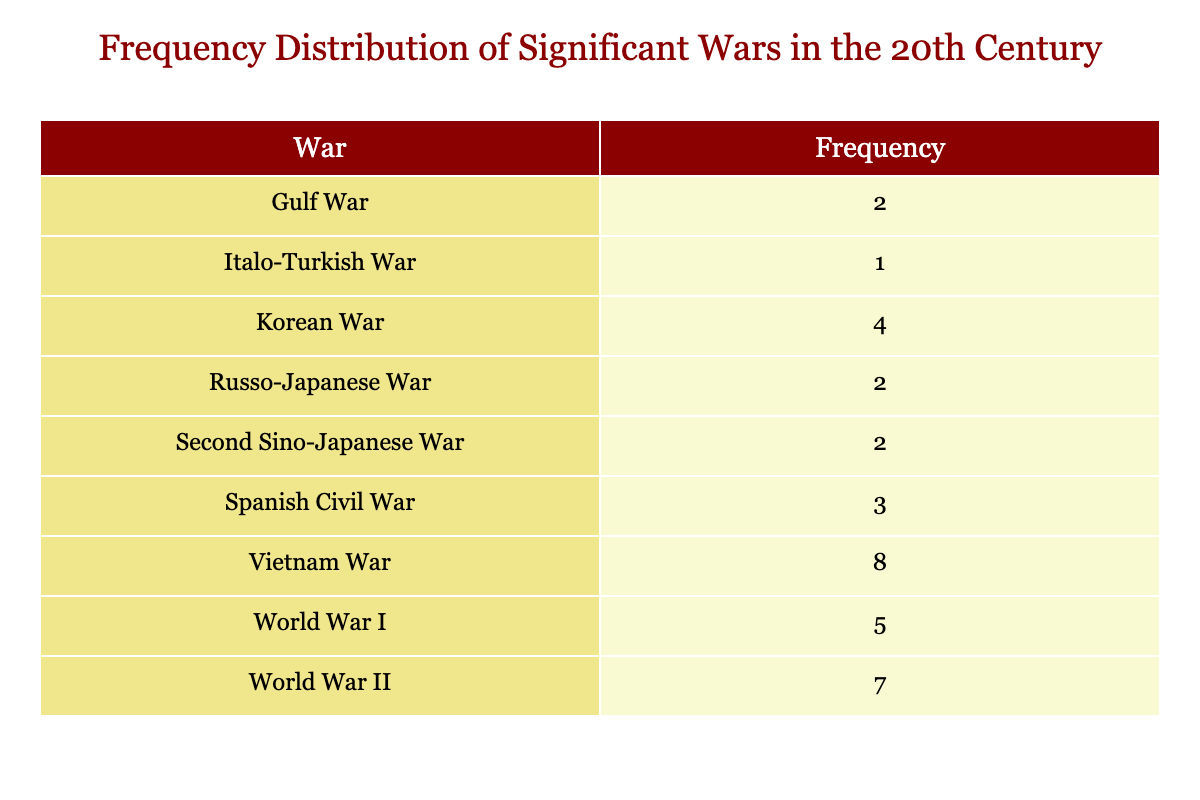What was the most frequent war in the 20th century according to the table? By examining the 'Frequency' column, we can identify the war with the highest count. The table indicates that the Vietnam War appears the most, with a frequency of 8.
Answer: Vietnam War How many significant wars occurred between 1940 and 1945? We look at the years from 1940 to 1945 in the table and count the wars listed: World War II occurred every year within this range. Thus, there is only one war during this time period.
Answer: 1 Is there any year without recorded wars? By scanning the 'Wars' column, multiple years show a '0' value indicating no wars occurred. For example, 1900 to 1903 shows no wars. Hence, the answer is yes.
Answer: Yes What is the total frequency of the wars listed in the table? We sum the frequencies of all wars: Russo-Japanese War (2) + Italo-Turkish War (1) + World War I (5) + Second Sino-Japanese War (2) + Spanish Civil War (3) + World War II (7) + Korean War (4) + Vietnam War (8) + Gulf War (2) = 34
Answer: 34 Which war had the longest span of years listed in the data? By inspecting the years associated with each war, the Vietnam War spans from 1964 to 1975, resulting in a total of 12 years (including both start and end years). Other wars like World War II and the Korean War also had multiple years, but the Vietnam War held the longest duration.
Answer: Vietnam War How many years did not have any significant wars? By reviewing the table, we count the years that are marked with '0.' There are numerous such years. After counting, we find there are 63 years without wars.
Answer: 63 Did the Korean War start before the Gulf War? Comparing the starting years of both wars shows that the Korean War began in 1950, while the Gulf War started in 1990. Thus, the Korean War did start earlier.
Answer: Yes What is the average number of wars per decade in the 20th century based on the table? We calculate the total wars (34) and divide by the number of decades (10). Thus, 34 divided by 10 equals 3.4 wars per decade on average.
Answer: 3.4 During which years did the Spanish Civil War occur? Examining the list, the Spanish Civil War is recorded in 1936, 1937, and 1938. Those specific years are when the war took place.
Answer: 1936, 1937, 1938 